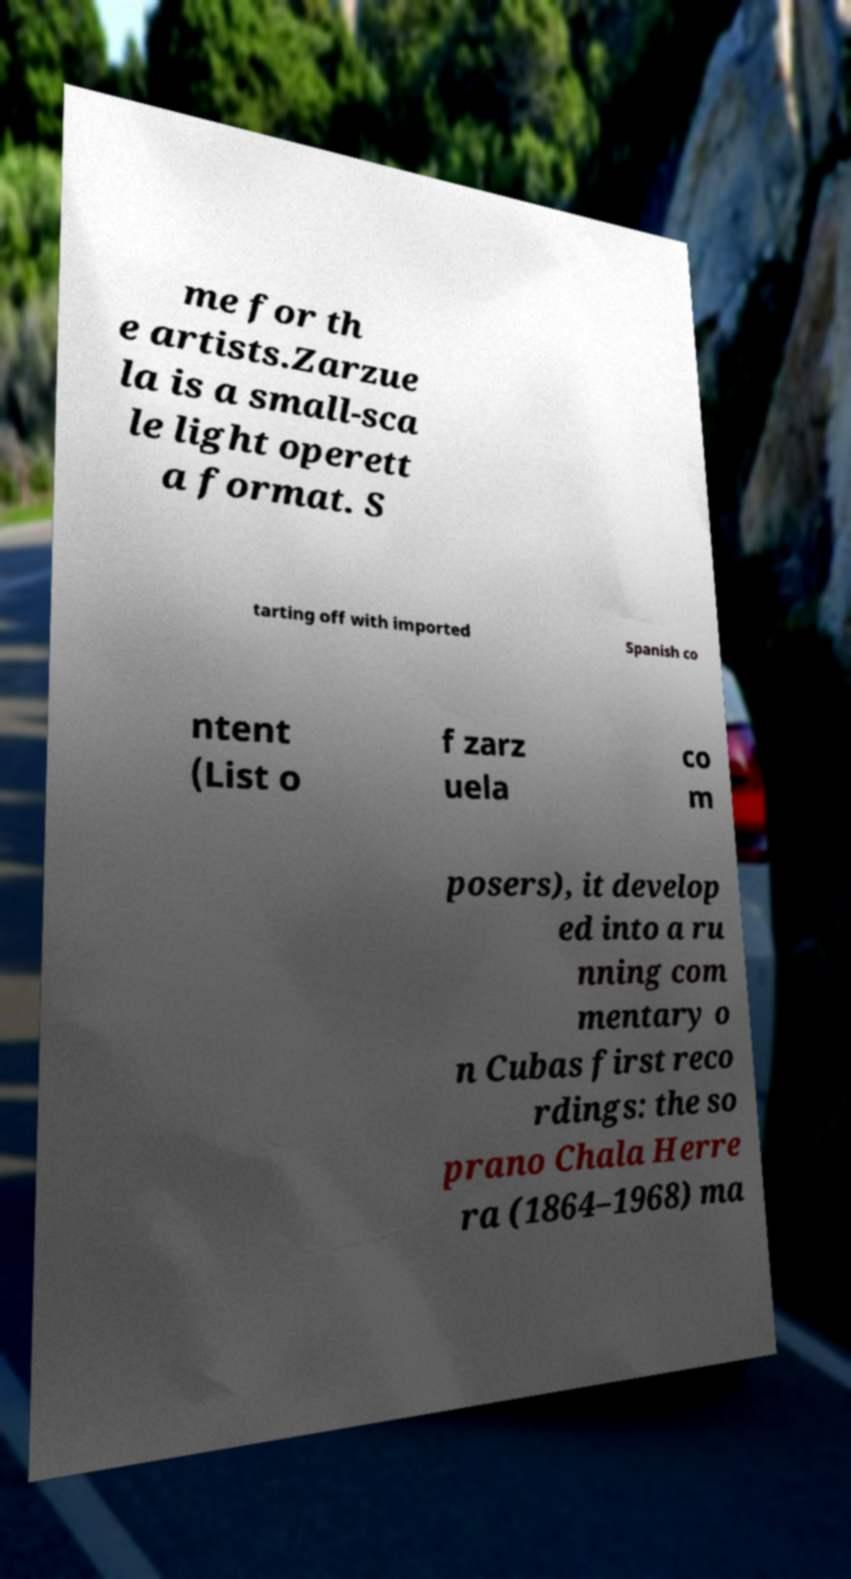Can you accurately transcribe the text from the provided image for me? me for th e artists.Zarzue la is a small-sca le light operett a format. S tarting off with imported Spanish co ntent (List o f zarz uela co m posers), it develop ed into a ru nning com mentary o n Cubas first reco rdings: the so prano Chala Herre ra (1864–1968) ma 